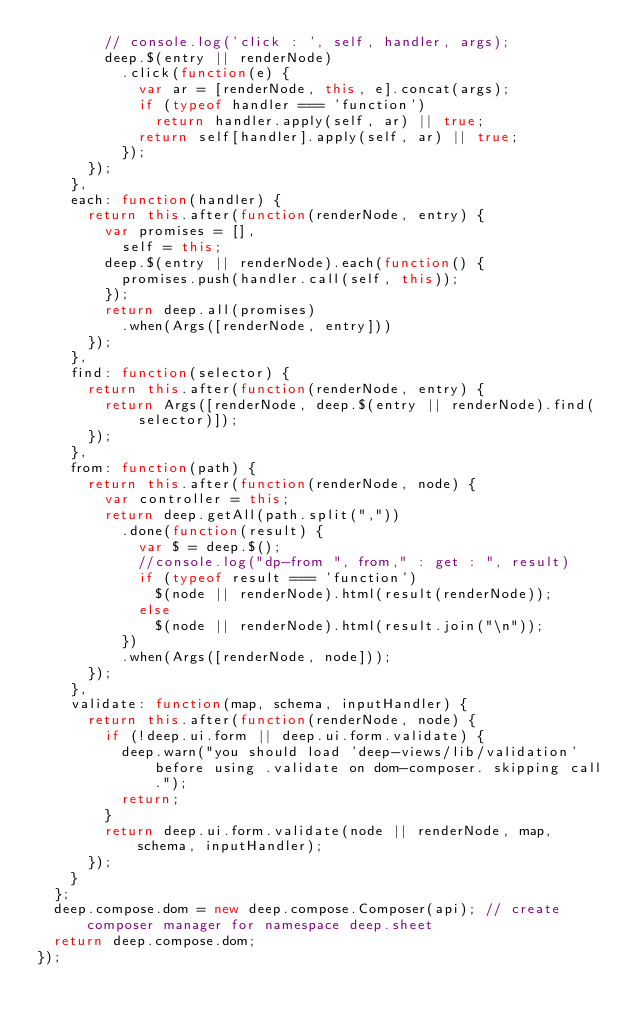<code> <loc_0><loc_0><loc_500><loc_500><_JavaScript_>				// console.log('click : ', self, handler, args);
				deep.$(entry || renderNode)
					.click(function(e) {
						var ar = [renderNode, this, e].concat(args);
						if (typeof handler === 'function')
							return handler.apply(self, ar) || true;
						return self[handler].apply(self, ar) || true;
					});
			});
		},
		each: function(handler) {
			return this.after(function(renderNode, entry) {
				var promises = [],
					self = this;
				deep.$(entry || renderNode).each(function() {
					promises.push(handler.call(self, this));
				});
				return deep.all(promises)
					.when(Args([renderNode, entry]))
			});
		},
		find: function(selector) {
			return this.after(function(renderNode, entry) {
				return Args([renderNode, deep.$(entry || renderNode).find(selector)]);
			});
		},
		from: function(path) {
			return this.after(function(renderNode, node) {
				var controller = this;
				return deep.getAll(path.split(","))
					.done(function(result) {
						var $ = deep.$();
						//console.log("dp-from ", from," : get : ", result)
						if (typeof result === 'function')
							$(node || renderNode).html(result(renderNode));
						else
							$(node || renderNode).html(result.join("\n"));
					})
					.when(Args([renderNode, node]));
			});
		},
		validate: function(map, schema, inputHandler) {
			return this.after(function(renderNode, node) {
				if (!deep.ui.form || deep.ui.form.validate) {
					deep.warn("you should load 'deep-views/lib/validation' before using .validate on dom-composer. skipping call.");
					return;
				}
				return deep.ui.form.validate(node || renderNode, map, schema, inputHandler);
			});
		}
	};
	deep.compose.dom = new deep.compose.Composer(api); // create composer manager for namespace deep.sheet 
	return deep.compose.dom;
});
</code> 